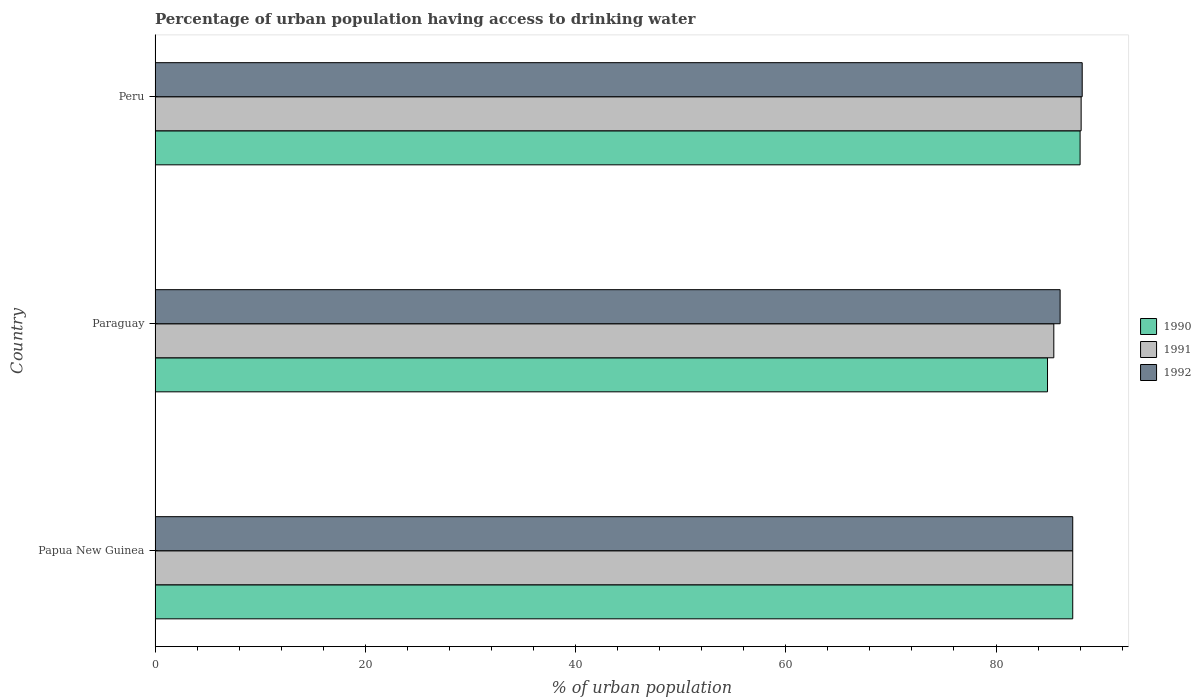How many different coloured bars are there?
Your answer should be compact. 3. How many groups of bars are there?
Keep it short and to the point. 3. Are the number of bars per tick equal to the number of legend labels?
Offer a very short reply. Yes. How many bars are there on the 1st tick from the top?
Keep it short and to the point. 3. How many bars are there on the 1st tick from the bottom?
Your answer should be compact. 3. In how many cases, is the number of bars for a given country not equal to the number of legend labels?
Make the answer very short. 0. What is the percentage of urban population having access to drinking water in 1990 in Papua New Guinea?
Your response must be concise. 87.3. Across all countries, what is the maximum percentage of urban population having access to drinking water in 1990?
Your answer should be compact. 88. Across all countries, what is the minimum percentage of urban population having access to drinking water in 1992?
Provide a succinct answer. 86.1. In which country was the percentage of urban population having access to drinking water in 1992 minimum?
Offer a terse response. Paraguay. What is the total percentage of urban population having access to drinking water in 1990 in the graph?
Offer a very short reply. 260.2. What is the difference between the percentage of urban population having access to drinking water in 1990 in Papua New Guinea and that in Peru?
Offer a very short reply. -0.7. What is the difference between the percentage of urban population having access to drinking water in 1991 in Peru and the percentage of urban population having access to drinking water in 1992 in Paraguay?
Ensure brevity in your answer.  2. What is the average percentage of urban population having access to drinking water in 1991 per country?
Keep it short and to the point. 86.97. What is the difference between the percentage of urban population having access to drinking water in 1991 and percentage of urban population having access to drinking water in 1990 in Paraguay?
Offer a terse response. 0.6. In how many countries, is the percentage of urban population having access to drinking water in 1990 greater than 32 %?
Offer a very short reply. 3. What is the ratio of the percentage of urban population having access to drinking water in 1990 in Paraguay to that in Peru?
Make the answer very short. 0.96. Is the percentage of urban population having access to drinking water in 1990 in Paraguay less than that in Peru?
Your answer should be compact. Yes. What is the difference between the highest and the second highest percentage of urban population having access to drinking water in 1991?
Keep it short and to the point. 0.8. What is the difference between the highest and the lowest percentage of urban population having access to drinking water in 1991?
Your response must be concise. 2.6. Is the sum of the percentage of urban population having access to drinking water in 1990 in Papua New Guinea and Paraguay greater than the maximum percentage of urban population having access to drinking water in 1991 across all countries?
Keep it short and to the point. Yes. How many bars are there?
Offer a terse response. 9. Are the values on the major ticks of X-axis written in scientific E-notation?
Your answer should be compact. No. Where does the legend appear in the graph?
Your answer should be very brief. Center right. What is the title of the graph?
Your response must be concise. Percentage of urban population having access to drinking water. What is the label or title of the X-axis?
Your answer should be compact. % of urban population. What is the % of urban population of 1990 in Papua New Guinea?
Your response must be concise. 87.3. What is the % of urban population in 1991 in Papua New Guinea?
Keep it short and to the point. 87.3. What is the % of urban population in 1992 in Papua New Guinea?
Make the answer very short. 87.3. What is the % of urban population in 1990 in Paraguay?
Provide a short and direct response. 84.9. What is the % of urban population of 1991 in Paraguay?
Provide a short and direct response. 85.5. What is the % of urban population of 1992 in Paraguay?
Keep it short and to the point. 86.1. What is the % of urban population in 1991 in Peru?
Offer a terse response. 88.1. What is the % of urban population in 1992 in Peru?
Ensure brevity in your answer.  88.2. Across all countries, what is the maximum % of urban population of 1991?
Offer a very short reply. 88.1. Across all countries, what is the maximum % of urban population in 1992?
Your answer should be very brief. 88.2. Across all countries, what is the minimum % of urban population of 1990?
Ensure brevity in your answer.  84.9. Across all countries, what is the minimum % of urban population in 1991?
Provide a short and direct response. 85.5. Across all countries, what is the minimum % of urban population in 1992?
Offer a very short reply. 86.1. What is the total % of urban population in 1990 in the graph?
Make the answer very short. 260.2. What is the total % of urban population of 1991 in the graph?
Ensure brevity in your answer.  260.9. What is the total % of urban population of 1992 in the graph?
Offer a very short reply. 261.6. What is the difference between the % of urban population of 1990 in Papua New Guinea and that in Paraguay?
Provide a succinct answer. 2.4. What is the difference between the % of urban population of 1992 in Papua New Guinea and that in Paraguay?
Your answer should be very brief. 1.2. What is the difference between the % of urban population of 1990 in Papua New Guinea and that in Peru?
Keep it short and to the point. -0.7. What is the difference between the % of urban population in 1992 in Papua New Guinea and that in Peru?
Offer a terse response. -0.9. What is the difference between the % of urban population of 1990 in Paraguay and that in Peru?
Provide a succinct answer. -3.1. What is the difference between the % of urban population of 1991 in Paraguay and that in Peru?
Your answer should be very brief. -2.6. What is the difference between the % of urban population in 1992 in Paraguay and that in Peru?
Provide a succinct answer. -2.1. What is the difference between the % of urban population of 1990 in Papua New Guinea and the % of urban population of 1991 in Paraguay?
Make the answer very short. 1.8. What is the difference between the % of urban population in 1991 in Papua New Guinea and the % of urban population in 1992 in Paraguay?
Make the answer very short. 1.2. What is the difference between the % of urban population in 1990 in Papua New Guinea and the % of urban population in 1992 in Peru?
Your answer should be very brief. -0.9. What is the average % of urban population of 1990 per country?
Your answer should be very brief. 86.73. What is the average % of urban population of 1991 per country?
Keep it short and to the point. 86.97. What is the average % of urban population in 1992 per country?
Give a very brief answer. 87.2. What is the difference between the % of urban population in 1990 and % of urban population in 1991 in Papua New Guinea?
Make the answer very short. 0. What is the difference between the % of urban population of 1991 and % of urban population of 1992 in Paraguay?
Offer a terse response. -0.6. What is the ratio of the % of urban population of 1990 in Papua New Guinea to that in Paraguay?
Make the answer very short. 1.03. What is the ratio of the % of urban population in 1991 in Papua New Guinea to that in Paraguay?
Provide a short and direct response. 1.02. What is the ratio of the % of urban population in 1992 in Papua New Guinea to that in Paraguay?
Offer a terse response. 1.01. What is the ratio of the % of urban population of 1990 in Papua New Guinea to that in Peru?
Keep it short and to the point. 0.99. What is the ratio of the % of urban population of 1991 in Papua New Guinea to that in Peru?
Your answer should be compact. 0.99. What is the ratio of the % of urban population in 1990 in Paraguay to that in Peru?
Offer a very short reply. 0.96. What is the ratio of the % of urban population of 1991 in Paraguay to that in Peru?
Offer a very short reply. 0.97. What is the ratio of the % of urban population of 1992 in Paraguay to that in Peru?
Offer a very short reply. 0.98. What is the difference between the highest and the second highest % of urban population of 1990?
Keep it short and to the point. 0.7. What is the difference between the highest and the second highest % of urban population in 1991?
Make the answer very short. 0.8. What is the difference between the highest and the second highest % of urban population in 1992?
Provide a succinct answer. 0.9. 